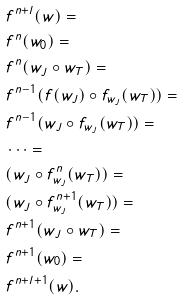<formula> <loc_0><loc_0><loc_500><loc_500>& f ^ { n + l } ( w ) = \\ & f ^ { n } ( w _ { 0 } ) = \\ & f ^ { n } ( w _ { J } \circ w _ { T } ) = \\ & f ^ { n - 1 } ( f ( w _ { J } ) \circ f _ { w _ { J } } ( w _ { T } ) ) = \\ & f ^ { n - 1 } ( w _ { J } \circ f _ { w _ { J } } ( w _ { T } ) ) = \\ & \cdots = \\ & ( w _ { J } \circ f ^ { n } _ { w _ { J } } ( w _ { T } ) ) = \\ & ( w _ { J } \circ f ^ { n + 1 } _ { w _ { J } } ( w _ { T } ) ) = \\ & f ^ { n + 1 } ( w _ { J } \circ w _ { T } ) = \\ & f ^ { n + 1 } ( w _ { 0 } ) = \\ & f ^ { n + l + 1 } ( w ) .</formula> 